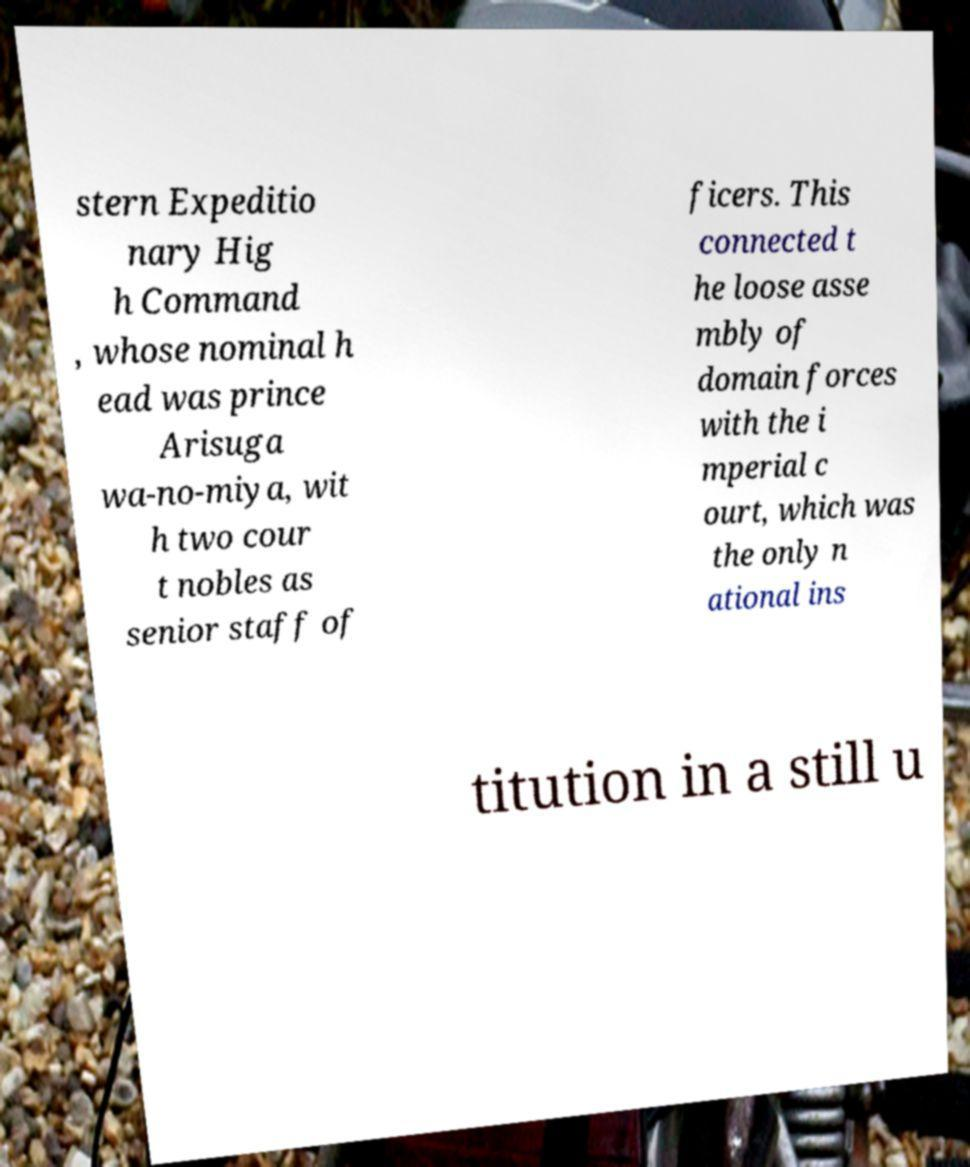Please identify and transcribe the text found in this image. stern Expeditio nary Hig h Command , whose nominal h ead was prince Arisuga wa-no-miya, wit h two cour t nobles as senior staff of ficers. This connected t he loose asse mbly of domain forces with the i mperial c ourt, which was the only n ational ins titution in a still u 